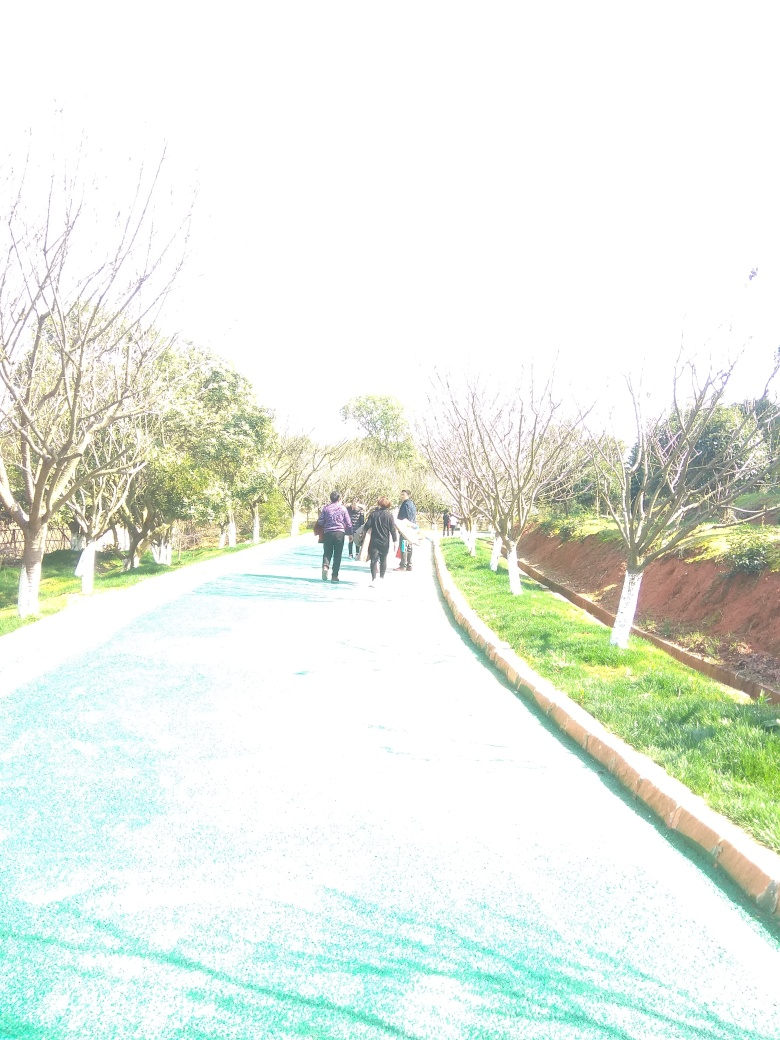What time of day does this photo appear to have been taken, based on the lighting? The photo seems to have been taken during the day when the sun is bright and high in the sky, as indicated by the overexposure and the long, but not overly extended shadows. This combination of lighting conditions suggests that it could be late morning or early afternoon. 